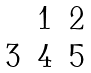Convert formula to latex. <formula><loc_0><loc_0><loc_500><loc_500>\begin{matrix} & 1 & 2 \\ 3 & 4 & 5 \end{matrix}</formula> 